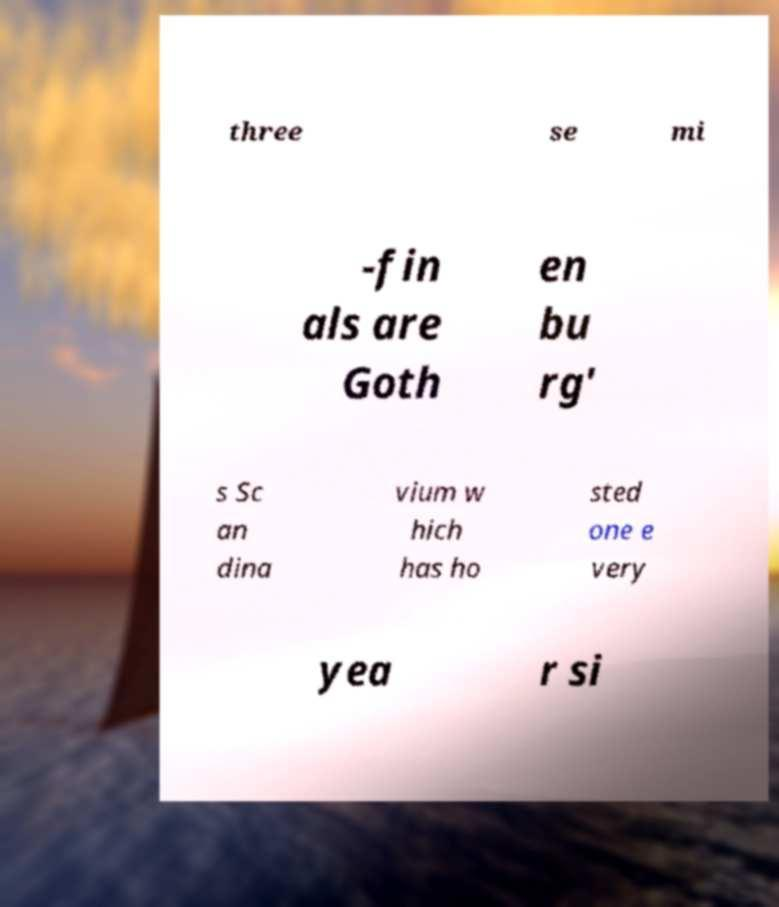Could you extract and type out the text from this image? three se mi -fin als are Goth en bu rg' s Sc an dina vium w hich has ho sted one e very yea r si 